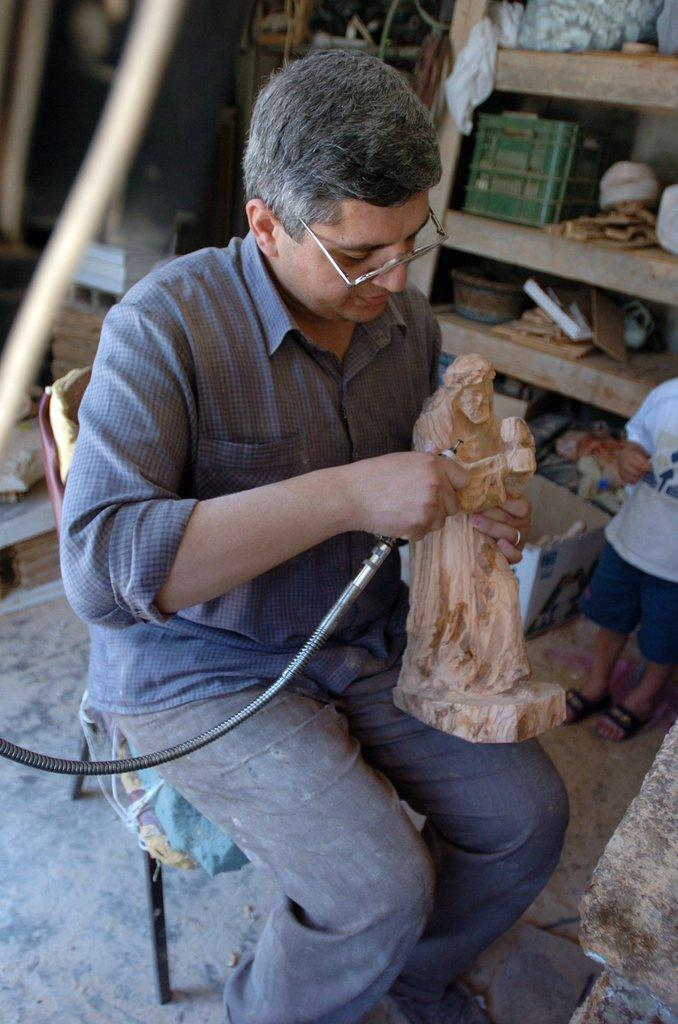What is the man in the image doing? The man is sitting on a chair in the image. What is the man holding in his hand? The man is holding a wooden sculpture. What is the object in the man's hand made of? The object in the man's hand is made of wood. What can be seen inside the rock in the image? There are things in the rock. What is on the floor in the image? There is a cardboard box on the floor. What is inside the cardboard box? There are things inside the cardboard box. Who else is present in the image? There is a kid in the image. What type of quartz can be seen on the man's wrist in the image? There is no quartz visible on the man's wrist in the image. What kind of watch is the man wearing in the image? The man is not wearing a watch in the image. 